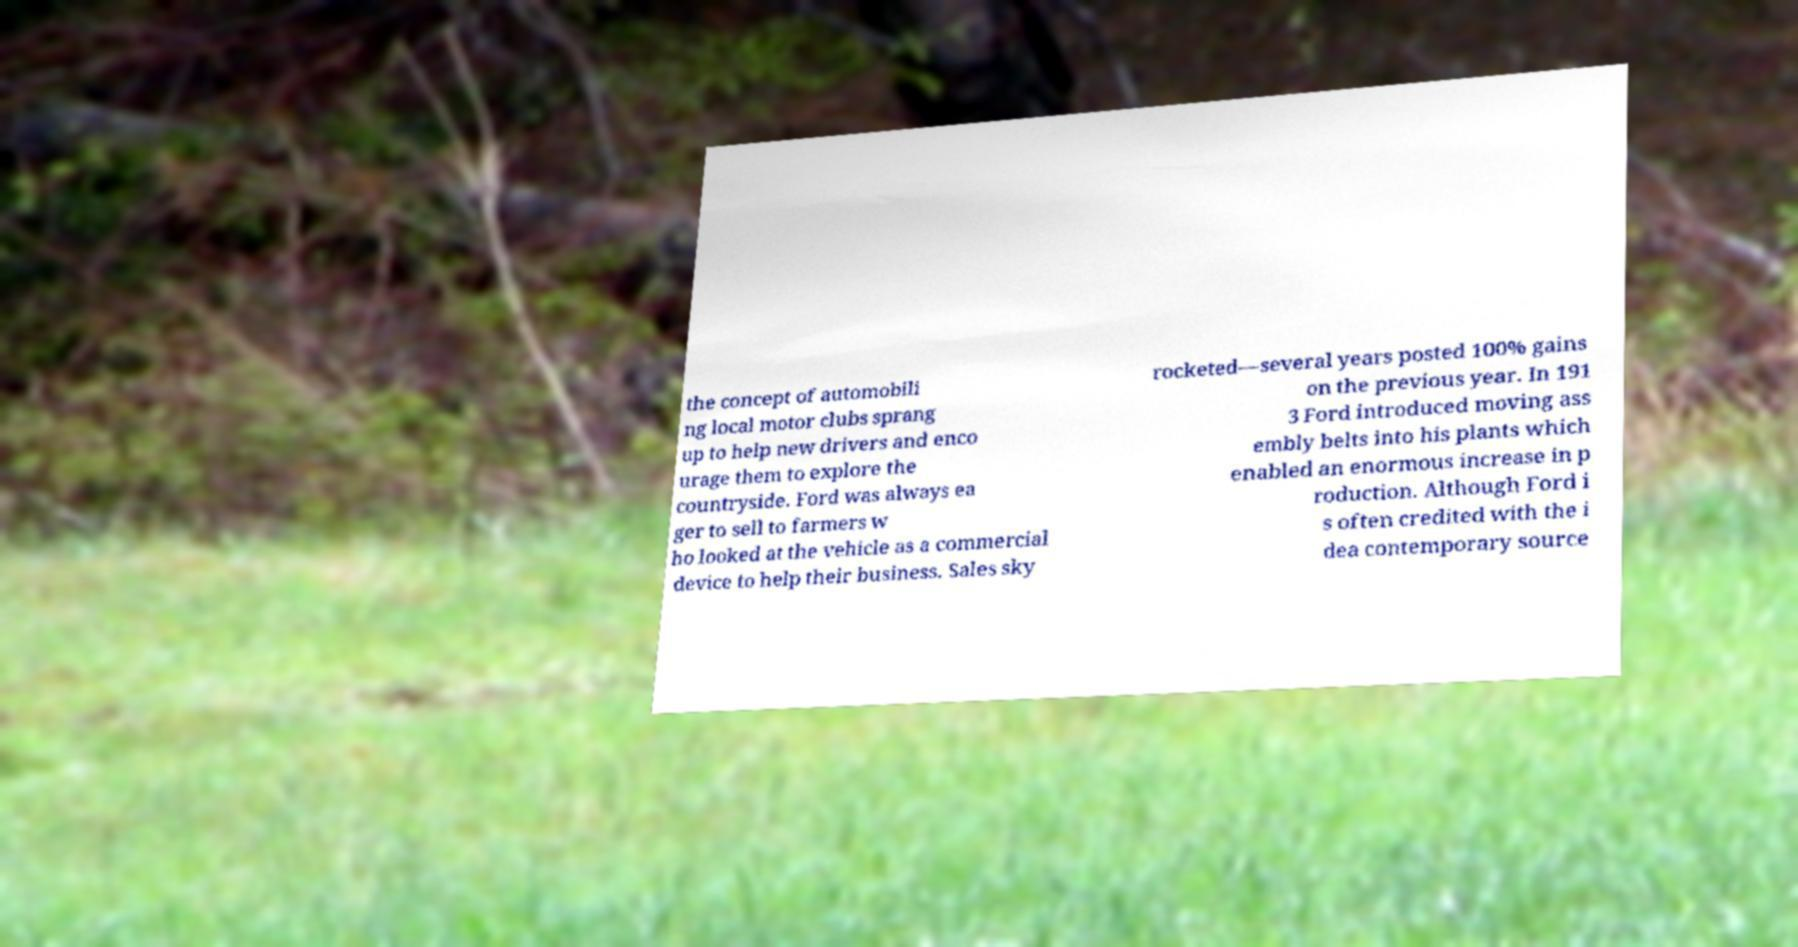There's text embedded in this image that I need extracted. Can you transcribe it verbatim? the concept of automobili ng local motor clubs sprang up to help new drivers and enco urage them to explore the countryside. Ford was always ea ger to sell to farmers w ho looked at the vehicle as a commercial device to help their business. Sales sky rocketed—several years posted 100% gains on the previous year. In 191 3 Ford introduced moving ass embly belts into his plants which enabled an enormous increase in p roduction. Although Ford i s often credited with the i dea contemporary source 